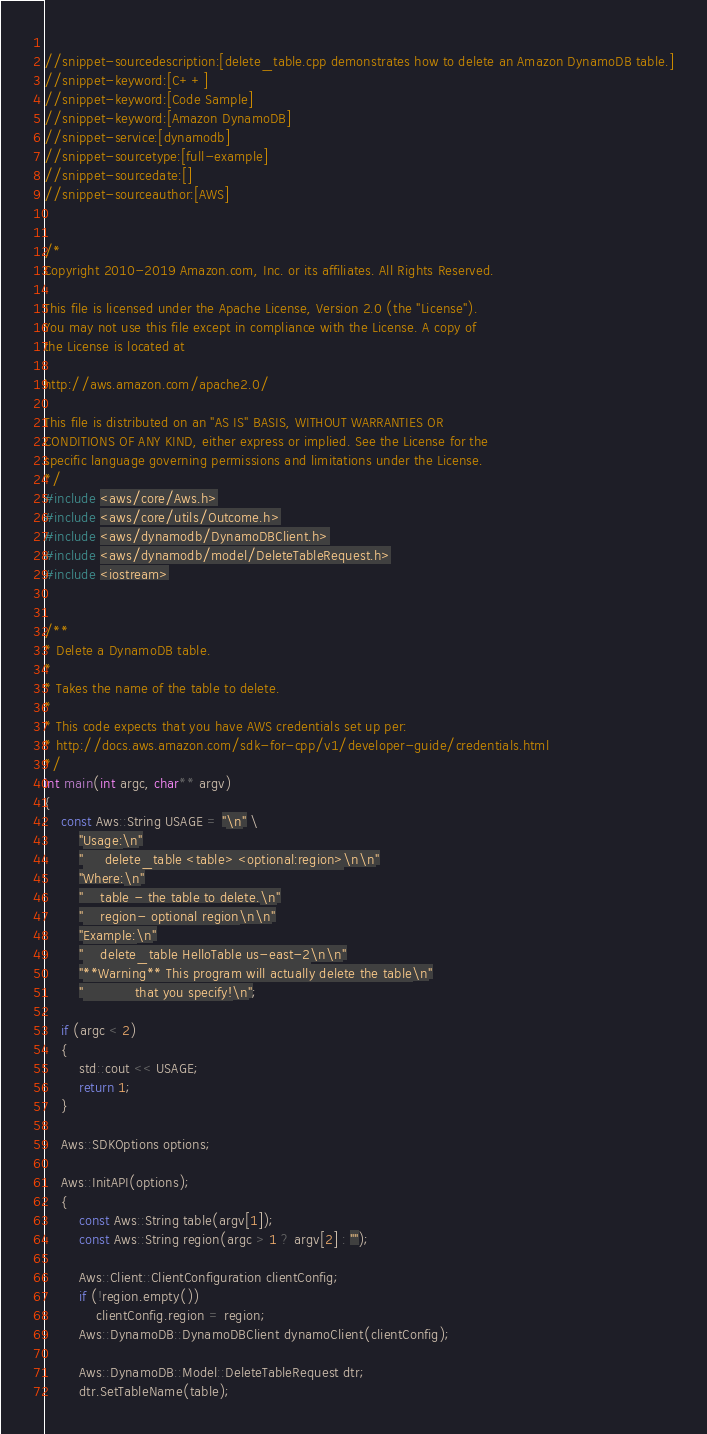<code> <loc_0><loc_0><loc_500><loc_500><_C++_> 
//snippet-sourcedescription:[delete_table.cpp demonstrates how to delete an Amazon DynamoDB table.]
//snippet-keyword:[C++]
//snippet-keyword:[Code Sample]
//snippet-keyword:[Amazon DynamoDB]
//snippet-service:[dynamodb]
//snippet-sourcetype:[full-example]
//snippet-sourcedate:[]
//snippet-sourceauthor:[AWS]


/*
Copyright 2010-2019 Amazon.com, Inc. or its affiliates. All Rights Reserved.

This file is licensed under the Apache License, Version 2.0 (the "License").
You may not use this file except in compliance with the License. A copy of
the License is located at

http://aws.amazon.com/apache2.0/

This file is distributed on an "AS IS" BASIS, WITHOUT WARRANTIES OR
CONDITIONS OF ANY KIND, either express or implied. See the License for the
specific language governing permissions and limitations under the License.
*/
#include <aws/core/Aws.h>
#include <aws/core/utils/Outcome.h> 
#include <aws/dynamodb/DynamoDBClient.h>
#include <aws/dynamodb/model/DeleteTableRequest.h>
#include <iostream>


/**
* Delete a DynamoDB table.
*
* Takes the name of the table to delete.
*
* This code expects that you have AWS credentials set up per:
* http://docs.aws.amazon.com/sdk-for-cpp/v1/developer-guide/credentials.html
*/
int main(int argc, char** argv)
{
    const Aws::String USAGE = "\n" \
        "Usage:\n"
        "     delete_table <table> <optional:region>\n\n"
        "Where:\n"
        "    table - the table to delete.\n"
        "    region- optional region\n\n"
        "Example:\n"
        "    delete_table HelloTable us-east-2\n\n"
        "**Warning** This program will actually delete the table\n"
        "            that you specify!\n";

    if (argc < 2)
    {
        std::cout << USAGE;
        return 1;
    }

    Aws::SDKOptions options;

    Aws::InitAPI(options);
    {
        const Aws::String table(argv[1]);
        const Aws::String region(argc > 1 ? argv[2] : "");

        Aws::Client::ClientConfiguration clientConfig;
        if (!region.empty())
            clientConfig.region = region;
        Aws::DynamoDB::DynamoDBClient dynamoClient(clientConfig);

        Aws::DynamoDB::Model::DeleteTableRequest dtr;
        dtr.SetTableName(table);
</code> 